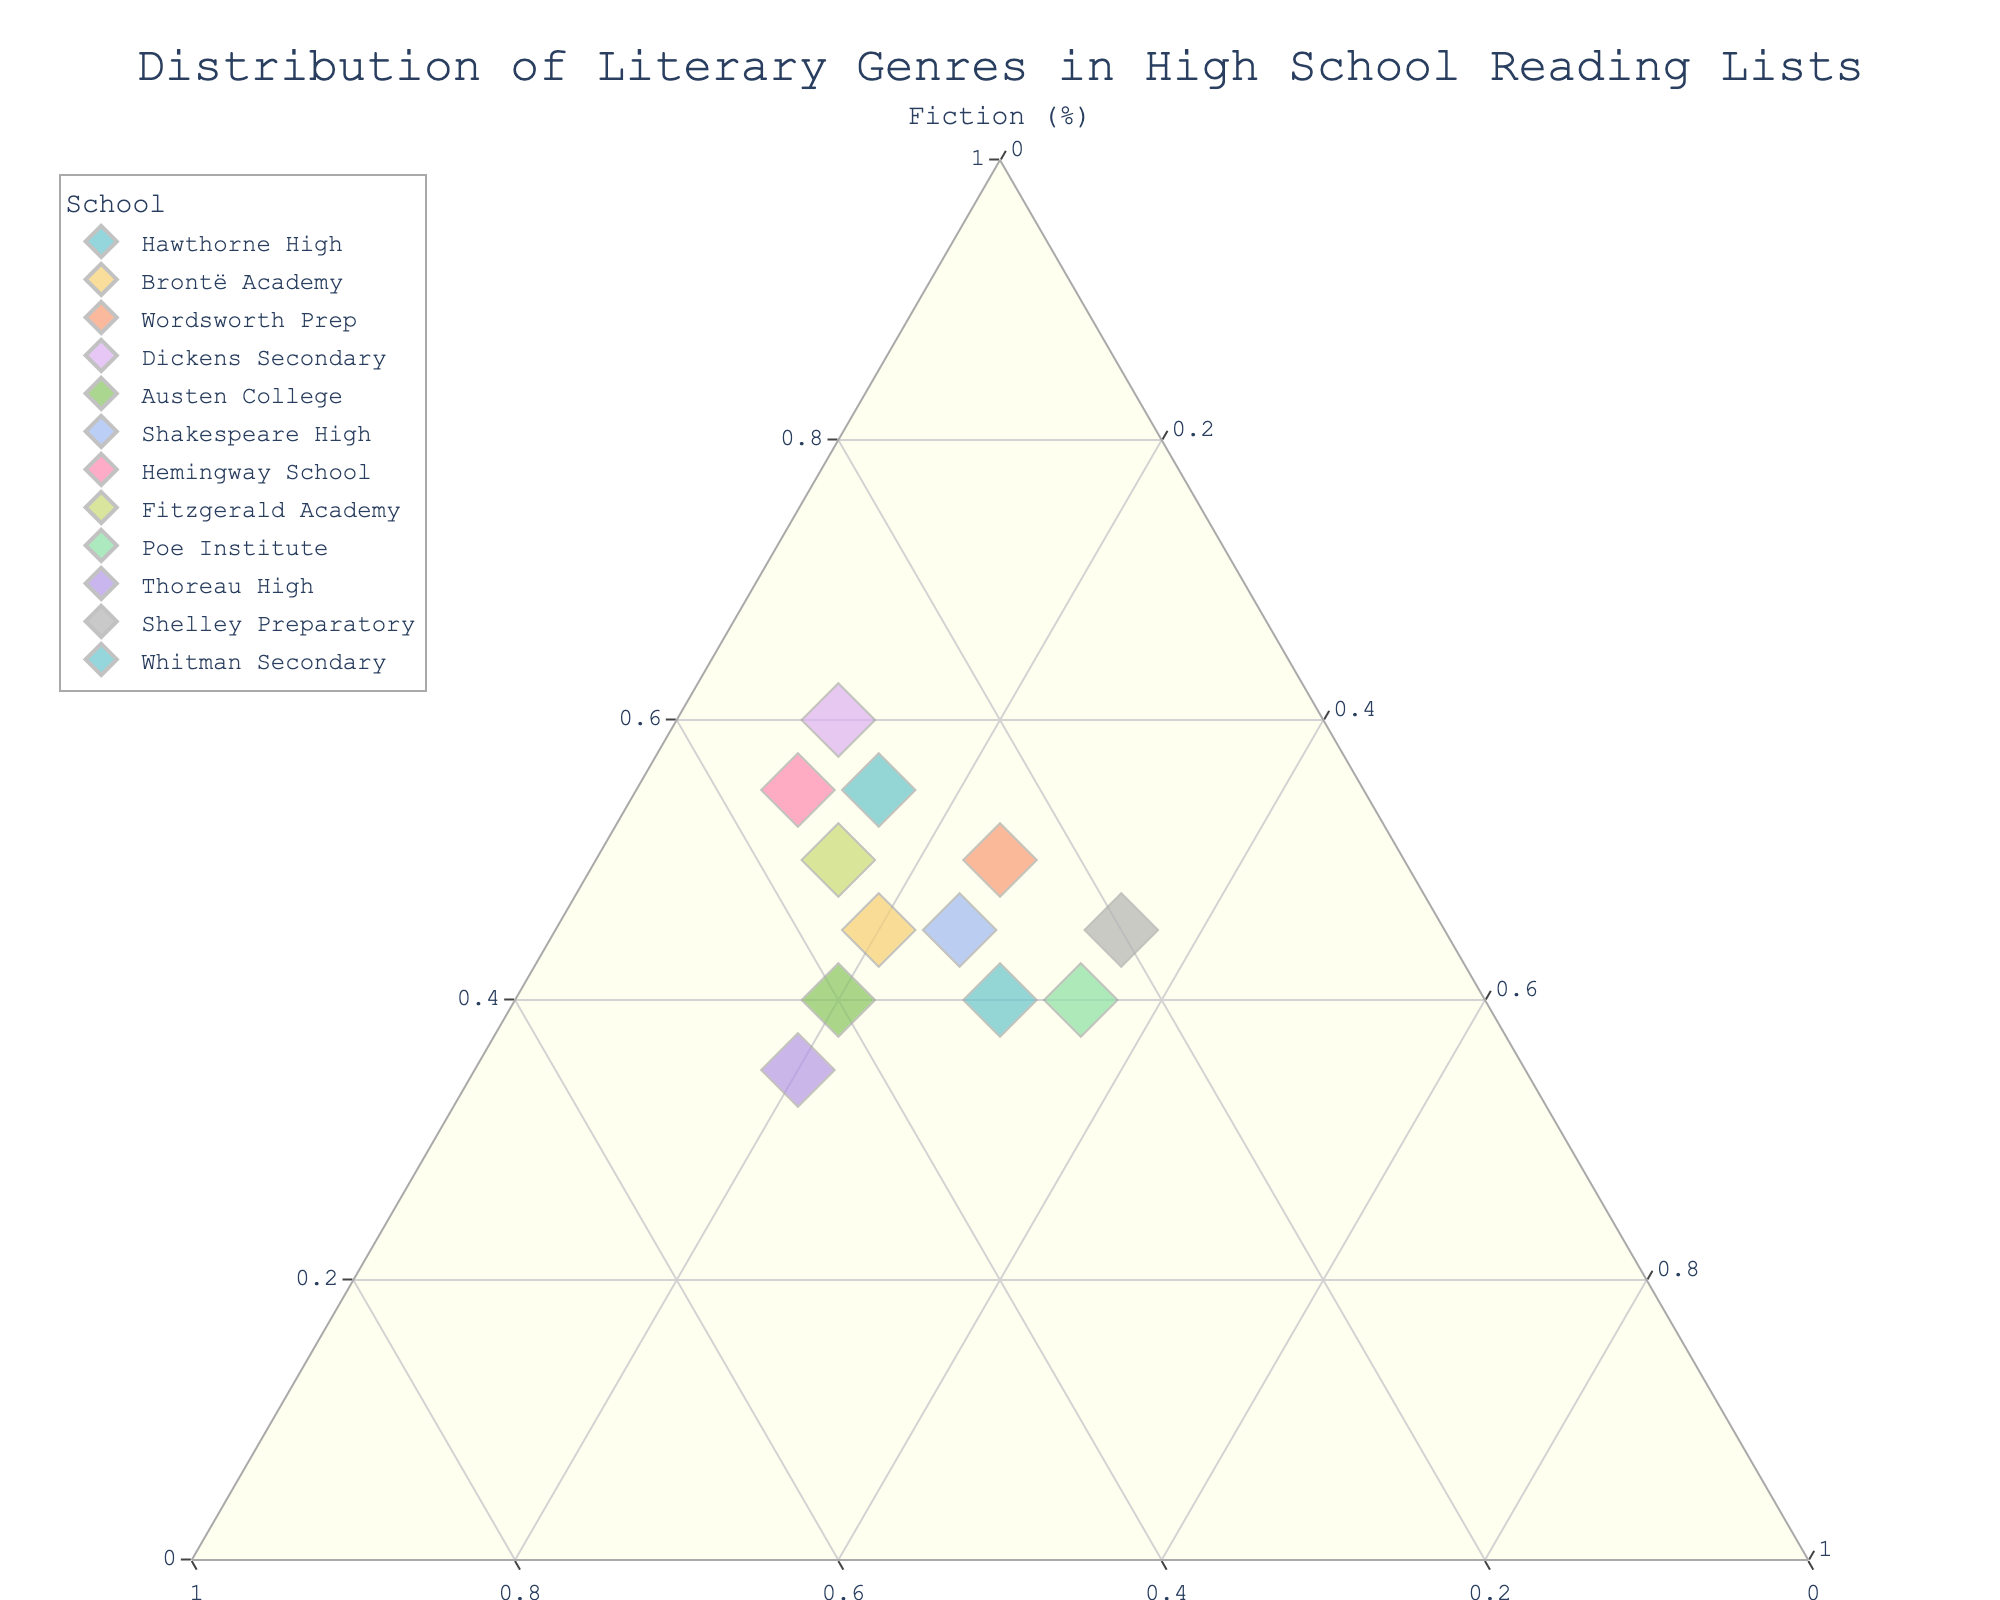What's the title of the figure? The title of the figure is usually positioned at the top. Looking there, we can see the title clearly.
Answer: Distribution of Literary Genres in High School Reading Lists How many schools are represented in the plot? Each school's distribution is indicated with a different marker in the plot. We count each unique marker.
Answer: 12 Which school has the highest percentage of Poetry in their reading list? By examining the plot, we look for the marker closest to the "Poetry" vertex. The closest marker to "Poetry" indicates the highest percentage.
Answer: Poe Institute Between Hawthorne High and Brontë Academy, which has a higher percentage of Fiction in their reading lists? Locate the markers for both schools and compare their positions along the Fiction axis. The marker higher up the Fiction axis has the higher percentage of Fiction.
Answer: Hawthorne High Which schools have an equal distribution of Non-Fiction and Poetry in their reading lists? By locating the markers along the midpoint of the Non-Fiction and Poetry axis, we can identify the schools that fall along this line.
Answer: Whitman Secondary What's the percentage composition of Fiction, Non-Fiction, and Poetry for Wordsworth Prep? Locate Wordsworth Prep on the ternary plot and read each percentage from the respective axes for Fiction, Non-Fiction, and Poetry.
Answer: Fiction: 50%, Non-Fiction: 25%, Poetry: 25% List the schools in descending order based on their Fiction percentages. By examining the positions along the Fiction axis, read off the percentages and list the schools from highest to lowest Fiction percentage.
Answer: Dickens Secondary, Hawthorne High, Hemingway School, Wordsworth Prep, Fitzgerald Academy, Brontë Academy, Shelley Preparatory, Shakespeare High, Whitman Secondary, Austen College, Poe Institute, Thoreau High Which school has the closest balance among Fiction, Non-Fiction, and Poetry? Identify the school whose marker is closest to the center of the ternary plot, indicating a near-equal distribution among all three genres.
Answer: Whitman Secondary 